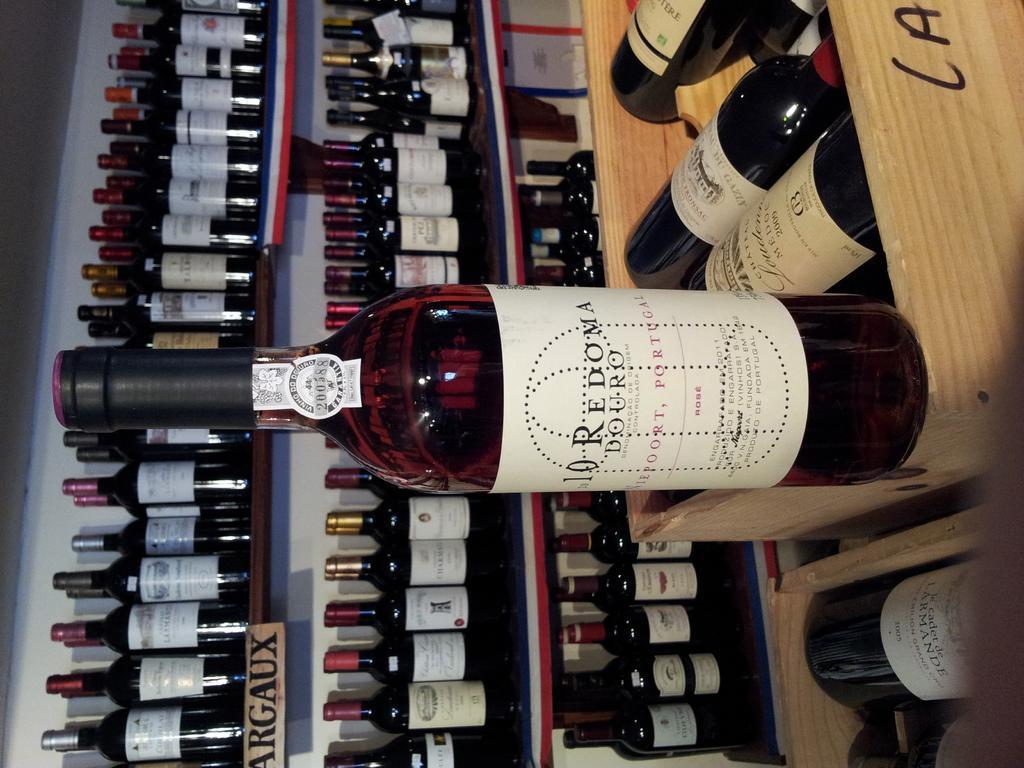In one or two sentences, can you explain what this image depicts? In this picture we can see in front bottle with sticker and in the background we can see so many bottles placed in the rack. 